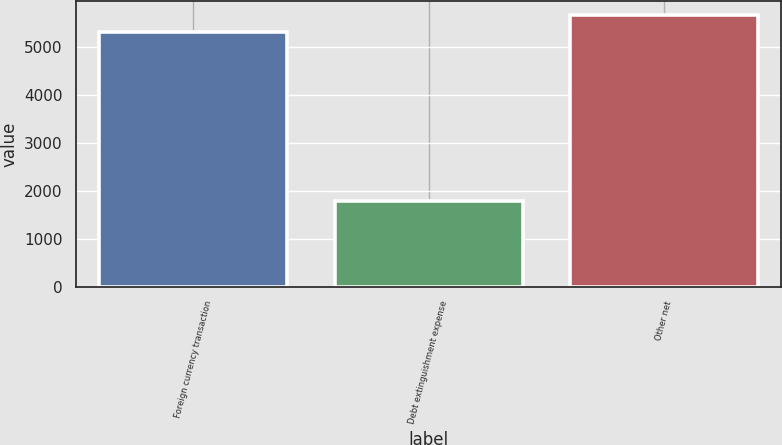Convert chart. <chart><loc_0><loc_0><loc_500><loc_500><bar_chart><fcel>Foreign currency transaction<fcel>Debt extinguishment expense<fcel>Other net<nl><fcel>5305<fcel>1792<fcel>5658.3<nl></chart> 